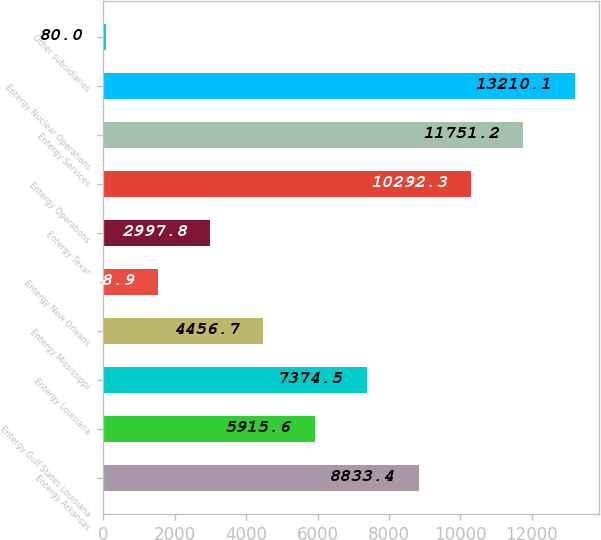<chart> <loc_0><loc_0><loc_500><loc_500><bar_chart><fcel>Entergy Arkansas<fcel>Entergy Gulf States Louisiana<fcel>Entergy Louisiana<fcel>Entergy Mississippi<fcel>Entergy New Orleans<fcel>Entergy Texas<fcel>Entergy Operations<fcel>Entergy Services<fcel>Entergy Nuclear Operations<fcel>Other subsidiaries<nl><fcel>8833.4<fcel>5915.6<fcel>7374.5<fcel>4456.7<fcel>1538.9<fcel>2997.8<fcel>10292.3<fcel>11751.2<fcel>13210.1<fcel>80<nl></chart> 